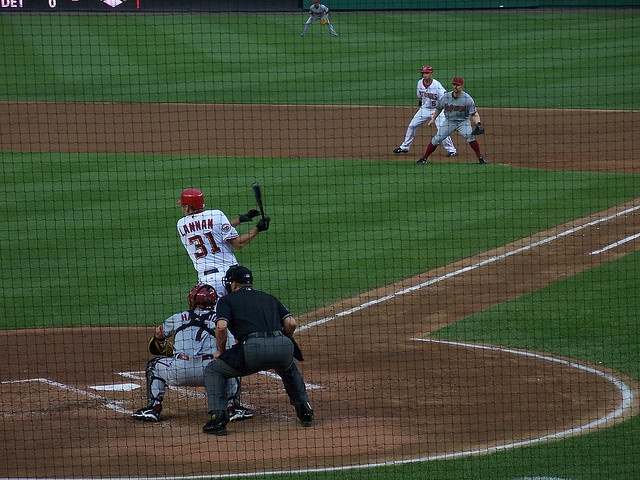Describe the objects in this image and their specific colors. I can see people in black, gray, and darkblue tones, people in black and gray tones, people in black, darkgray, lavender, and maroon tones, people in black and gray tones, and people in black, gray, darkgray, and lightblue tones in this image. 